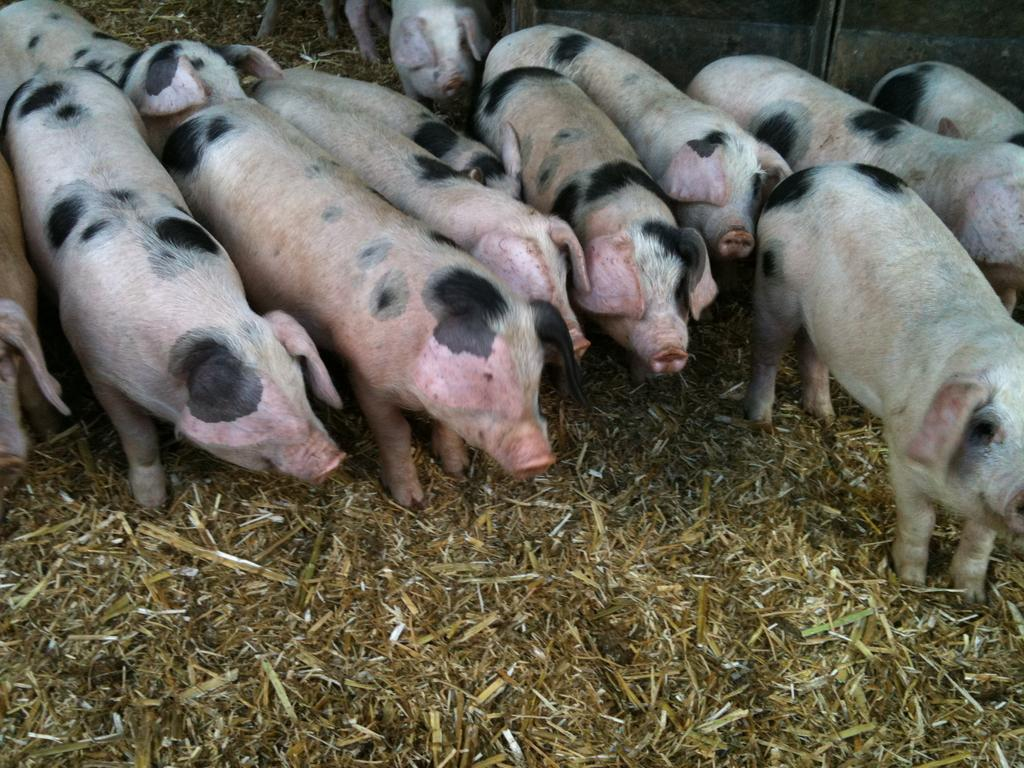What type of animals are present in the image? There are pigs in the image. Where are the pigs located? The pigs are on the surface. What type of protest is happening in the image? There is no protest present in the image; it features pigs on the surface. Is there a bridge visible in the image? There is no bridge present in the image. 